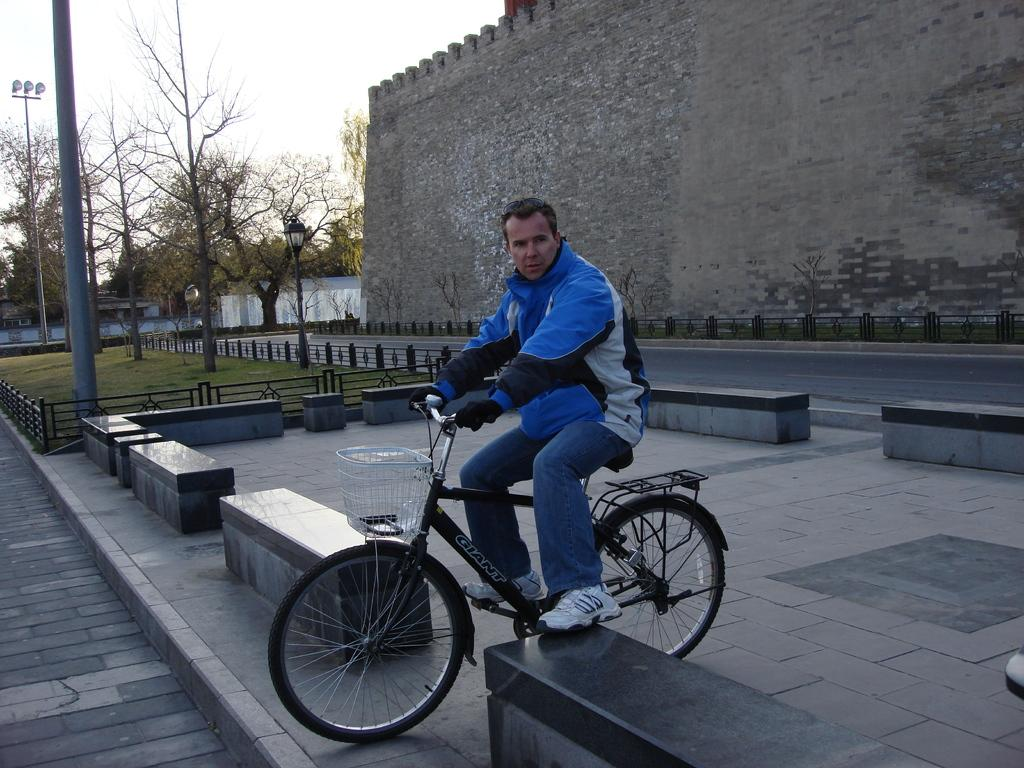What is the person in the image doing? The person is riding a bicycle on the road. What can be seen near the person? There are many branches near the person. What type of vegetation is present in the image? There are trees in the vicinity. What structure is visible in the image? There is a building visible. What is the condition of the sky in the image? The sky is clear in the image. How many trains can be seen in the image? There are no trains present in the image. What type of crowd is visible near the person riding the bicycle? There is no crowd visible in the image; the person is riding a bicycle on the road with branches and trees nearby. 